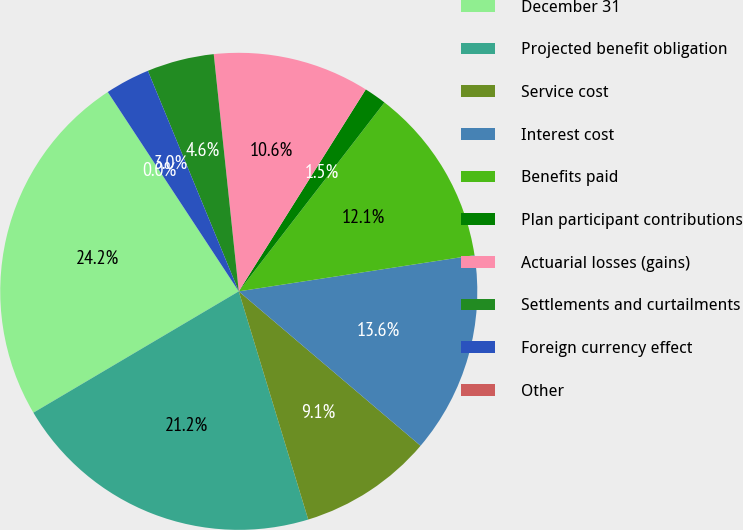Convert chart. <chart><loc_0><loc_0><loc_500><loc_500><pie_chart><fcel>December 31<fcel>Projected benefit obligation<fcel>Service cost<fcel>Interest cost<fcel>Benefits paid<fcel>Plan participant contributions<fcel>Actuarial losses (gains)<fcel>Settlements and curtailments<fcel>Foreign currency effect<fcel>Other<nl><fcel>24.24%<fcel>21.21%<fcel>9.09%<fcel>13.63%<fcel>12.12%<fcel>1.52%<fcel>10.61%<fcel>4.55%<fcel>3.03%<fcel>0.0%<nl></chart> 